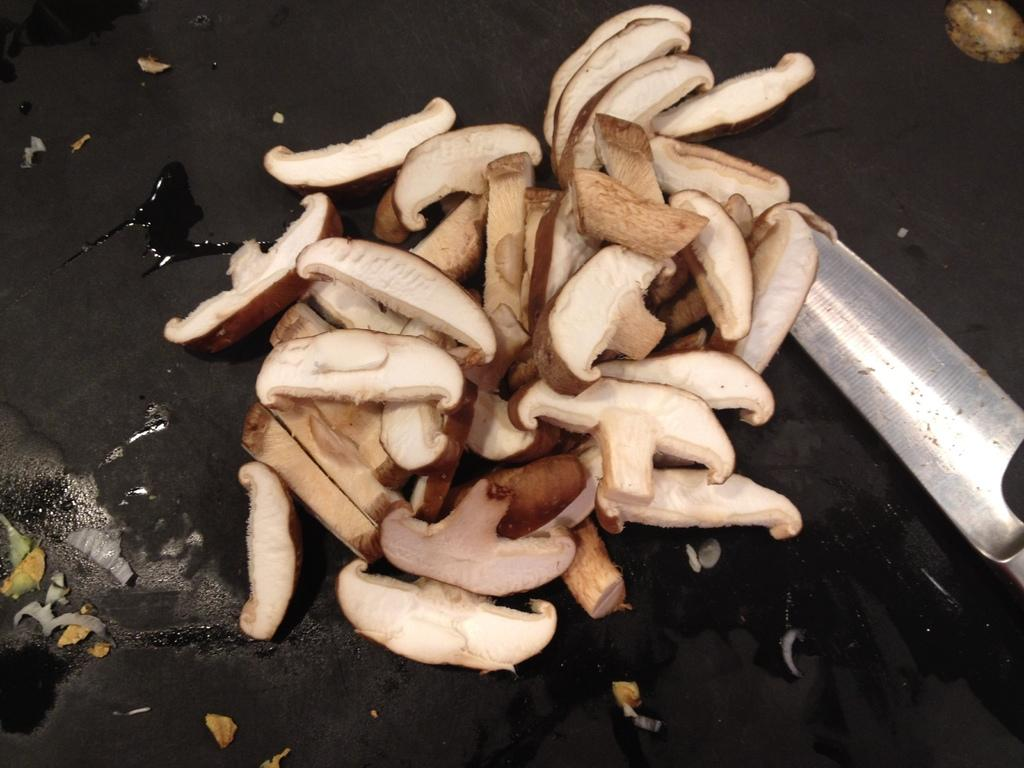What type of fungi can be seen in the image? There are mushrooms in the image. What utensil is present in the image? There is a knife in the image. What color is the background of the image? The background of the image is black. What might be used for cooking in the image? The object that might be a pan is present in the image. How many lizards can be seen crawling on the street in the image? There are no lizards or streets present in the image. What type of polish is applied to the object in the image? There is no polish or object that requires polishing present in the image. 